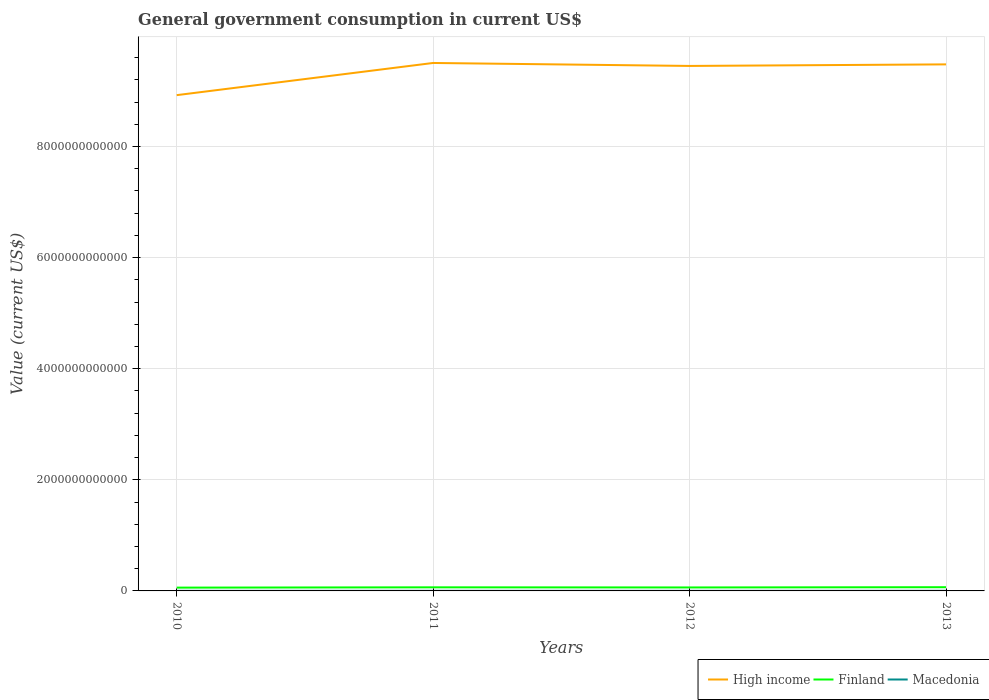How many different coloured lines are there?
Offer a very short reply. 3. Across all years, what is the maximum government conusmption in High income?
Give a very brief answer. 8.92e+12. In which year was the government conusmption in Macedonia maximum?
Keep it short and to the point. 2010. What is the total government conusmption in Macedonia in the graph?
Your answer should be very brief. -9.67e+07. What is the difference between the highest and the second highest government conusmption in High income?
Your answer should be very brief. 5.79e+11. Is the government conusmption in Finland strictly greater than the government conusmption in Macedonia over the years?
Your response must be concise. No. What is the difference between two consecutive major ticks on the Y-axis?
Provide a succinct answer. 2.00e+12. Does the graph contain any zero values?
Your answer should be compact. No. Where does the legend appear in the graph?
Provide a short and direct response. Bottom right. How many legend labels are there?
Your response must be concise. 3. How are the legend labels stacked?
Make the answer very short. Horizontal. What is the title of the graph?
Your answer should be compact. General government consumption in current US$. Does "Czech Republic" appear as one of the legend labels in the graph?
Your answer should be very brief. No. What is the label or title of the Y-axis?
Offer a very short reply. Value (current US$). What is the Value (current US$) of High income in 2010?
Your answer should be compact. 8.92e+12. What is the Value (current US$) in Finland in 2010?
Your answer should be compact. 5.92e+1. What is the Value (current US$) in Macedonia in 2010?
Ensure brevity in your answer.  1.72e+09. What is the Value (current US$) in High income in 2011?
Ensure brevity in your answer.  9.50e+12. What is the Value (current US$) of Finland in 2011?
Your answer should be very brief. 6.46e+1. What is the Value (current US$) in Macedonia in 2011?
Give a very brief answer. 1.90e+09. What is the Value (current US$) in High income in 2012?
Make the answer very short. 9.45e+12. What is the Value (current US$) in Finland in 2012?
Your answer should be very brief. 6.25e+1. What is the Value (current US$) in Macedonia in 2012?
Offer a very short reply. 1.82e+09. What is the Value (current US$) in High income in 2013?
Provide a succinct answer. 9.48e+12. What is the Value (current US$) of Finland in 2013?
Give a very brief answer. 6.68e+1. What is the Value (current US$) of Macedonia in 2013?
Ensure brevity in your answer.  1.91e+09. Across all years, what is the maximum Value (current US$) in High income?
Give a very brief answer. 9.50e+12. Across all years, what is the maximum Value (current US$) of Finland?
Ensure brevity in your answer.  6.68e+1. Across all years, what is the maximum Value (current US$) of Macedonia?
Provide a succinct answer. 1.91e+09. Across all years, what is the minimum Value (current US$) in High income?
Ensure brevity in your answer.  8.92e+12. Across all years, what is the minimum Value (current US$) of Finland?
Keep it short and to the point. 5.92e+1. Across all years, what is the minimum Value (current US$) of Macedonia?
Provide a short and direct response. 1.72e+09. What is the total Value (current US$) of High income in the graph?
Provide a short and direct response. 3.74e+13. What is the total Value (current US$) of Finland in the graph?
Provide a succinct answer. 2.53e+11. What is the total Value (current US$) of Macedonia in the graph?
Provide a succinct answer. 7.35e+09. What is the difference between the Value (current US$) in High income in 2010 and that in 2011?
Offer a terse response. -5.79e+11. What is the difference between the Value (current US$) in Finland in 2010 and that in 2011?
Give a very brief answer. -5.42e+09. What is the difference between the Value (current US$) of Macedonia in 2010 and that in 2011?
Offer a terse response. -1.81e+08. What is the difference between the Value (current US$) in High income in 2010 and that in 2012?
Your answer should be compact. -5.26e+11. What is the difference between the Value (current US$) of Finland in 2010 and that in 2012?
Offer a very short reply. -3.34e+09. What is the difference between the Value (current US$) of Macedonia in 2010 and that in 2012?
Give a very brief answer. -9.67e+07. What is the difference between the Value (current US$) of High income in 2010 and that in 2013?
Make the answer very short. -5.54e+11. What is the difference between the Value (current US$) of Finland in 2010 and that in 2013?
Your answer should be compact. -7.59e+09. What is the difference between the Value (current US$) of Macedonia in 2010 and that in 2013?
Offer a terse response. -1.86e+08. What is the difference between the Value (current US$) in High income in 2011 and that in 2012?
Your response must be concise. 5.35e+1. What is the difference between the Value (current US$) in Finland in 2011 and that in 2012?
Your answer should be compact. 2.08e+09. What is the difference between the Value (current US$) in Macedonia in 2011 and that in 2012?
Ensure brevity in your answer.  8.44e+07. What is the difference between the Value (current US$) in High income in 2011 and that in 2013?
Ensure brevity in your answer.  2.52e+1. What is the difference between the Value (current US$) of Finland in 2011 and that in 2013?
Keep it short and to the point. -2.18e+09. What is the difference between the Value (current US$) in Macedonia in 2011 and that in 2013?
Your answer should be compact. -4.93e+06. What is the difference between the Value (current US$) in High income in 2012 and that in 2013?
Offer a very short reply. -2.83e+1. What is the difference between the Value (current US$) of Finland in 2012 and that in 2013?
Offer a terse response. -4.25e+09. What is the difference between the Value (current US$) in Macedonia in 2012 and that in 2013?
Offer a very short reply. -8.93e+07. What is the difference between the Value (current US$) in High income in 2010 and the Value (current US$) in Finland in 2011?
Offer a terse response. 8.86e+12. What is the difference between the Value (current US$) in High income in 2010 and the Value (current US$) in Macedonia in 2011?
Provide a short and direct response. 8.92e+12. What is the difference between the Value (current US$) in Finland in 2010 and the Value (current US$) in Macedonia in 2011?
Your response must be concise. 5.73e+1. What is the difference between the Value (current US$) in High income in 2010 and the Value (current US$) in Finland in 2012?
Your answer should be very brief. 8.86e+12. What is the difference between the Value (current US$) of High income in 2010 and the Value (current US$) of Macedonia in 2012?
Offer a very short reply. 8.92e+12. What is the difference between the Value (current US$) in Finland in 2010 and the Value (current US$) in Macedonia in 2012?
Give a very brief answer. 5.74e+1. What is the difference between the Value (current US$) of High income in 2010 and the Value (current US$) of Finland in 2013?
Provide a short and direct response. 8.86e+12. What is the difference between the Value (current US$) in High income in 2010 and the Value (current US$) in Macedonia in 2013?
Your answer should be compact. 8.92e+12. What is the difference between the Value (current US$) in Finland in 2010 and the Value (current US$) in Macedonia in 2013?
Ensure brevity in your answer.  5.73e+1. What is the difference between the Value (current US$) in High income in 2011 and the Value (current US$) in Finland in 2012?
Offer a very short reply. 9.44e+12. What is the difference between the Value (current US$) in High income in 2011 and the Value (current US$) in Macedonia in 2012?
Your response must be concise. 9.50e+12. What is the difference between the Value (current US$) in Finland in 2011 and the Value (current US$) in Macedonia in 2012?
Keep it short and to the point. 6.28e+1. What is the difference between the Value (current US$) in High income in 2011 and the Value (current US$) in Finland in 2013?
Give a very brief answer. 9.44e+12. What is the difference between the Value (current US$) in High income in 2011 and the Value (current US$) in Macedonia in 2013?
Give a very brief answer. 9.50e+12. What is the difference between the Value (current US$) in Finland in 2011 and the Value (current US$) in Macedonia in 2013?
Offer a very short reply. 6.27e+1. What is the difference between the Value (current US$) of High income in 2012 and the Value (current US$) of Finland in 2013?
Your response must be concise. 9.38e+12. What is the difference between the Value (current US$) in High income in 2012 and the Value (current US$) in Macedonia in 2013?
Ensure brevity in your answer.  9.45e+12. What is the difference between the Value (current US$) of Finland in 2012 and the Value (current US$) of Macedonia in 2013?
Provide a short and direct response. 6.06e+1. What is the average Value (current US$) of High income per year?
Keep it short and to the point. 9.34e+12. What is the average Value (current US$) of Finland per year?
Keep it short and to the point. 6.33e+1. What is the average Value (current US$) of Macedonia per year?
Offer a very short reply. 1.84e+09. In the year 2010, what is the difference between the Value (current US$) in High income and Value (current US$) in Finland?
Offer a very short reply. 8.86e+12. In the year 2010, what is the difference between the Value (current US$) of High income and Value (current US$) of Macedonia?
Offer a very short reply. 8.92e+12. In the year 2010, what is the difference between the Value (current US$) of Finland and Value (current US$) of Macedonia?
Give a very brief answer. 5.75e+1. In the year 2011, what is the difference between the Value (current US$) in High income and Value (current US$) in Finland?
Offer a terse response. 9.44e+12. In the year 2011, what is the difference between the Value (current US$) of High income and Value (current US$) of Macedonia?
Ensure brevity in your answer.  9.50e+12. In the year 2011, what is the difference between the Value (current US$) in Finland and Value (current US$) in Macedonia?
Provide a succinct answer. 6.27e+1. In the year 2012, what is the difference between the Value (current US$) of High income and Value (current US$) of Finland?
Your response must be concise. 9.39e+12. In the year 2012, what is the difference between the Value (current US$) of High income and Value (current US$) of Macedonia?
Provide a short and direct response. 9.45e+12. In the year 2012, what is the difference between the Value (current US$) of Finland and Value (current US$) of Macedonia?
Offer a very short reply. 6.07e+1. In the year 2013, what is the difference between the Value (current US$) of High income and Value (current US$) of Finland?
Offer a very short reply. 9.41e+12. In the year 2013, what is the difference between the Value (current US$) in High income and Value (current US$) in Macedonia?
Give a very brief answer. 9.48e+12. In the year 2013, what is the difference between the Value (current US$) in Finland and Value (current US$) in Macedonia?
Offer a terse response. 6.49e+1. What is the ratio of the Value (current US$) of High income in 2010 to that in 2011?
Keep it short and to the point. 0.94. What is the ratio of the Value (current US$) in Finland in 2010 to that in 2011?
Keep it short and to the point. 0.92. What is the ratio of the Value (current US$) in Macedonia in 2010 to that in 2011?
Your answer should be compact. 0.9. What is the ratio of the Value (current US$) of High income in 2010 to that in 2012?
Ensure brevity in your answer.  0.94. What is the ratio of the Value (current US$) of Finland in 2010 to that in 2012?
Your answer should be very brief. 0.95. What is the ratio of the Value (current US$) of Macedonia in 2010 to that in 2012?
Provide a succinct answer. 0.95. What is the ratio of the Value (current US$) in High income in 2010 to that in 2013?
Offer a terse response. 0.94. What is the ratio of the Value (current US$) of Finland in 2010 to that in 2013?
Provide a succinct answer. 0.89. What is the ratio of the Value (current US$) in Macedonia in 2010 to that in 2013?
Provide a short and direct response. 0.9. What is the ratio of the Value (current US$) in High income in 2011 to that in 2012?
Offer a terse response. 1.01. What is the ratio of the Value (current US$) in Finland in 2011 to that in 2012?
Offer a very short reply. 1.03. What is the ratio of the Value (current US$) in Macedonia in 2011 to that in 2012?
Provide a short and direct response. 1.05. What is the ratio of the Value (current US$) in High income in 2011 to that in 2013?
Give a very brief answer. 1. What is the ratio of the Value (current US$) in Finland in 2011 to that in 2013?
Your answer should be compact. 0.97. What is the ratio of the Value (current US$) in Macedonia in 2011 to that in 2013?
Make the answer very short. 1. What is the ratio of the Value (current US$) in High income in 2012 to that in 2013?
Provide a succinct answer. 1. What is the ratio of the Value (current US$) in Finland in 2012 to that in 2013?
Give a very brief answer. 0.94. What is the ratio of the Value (current US$) in Macedonia in 2012 to that in 2013?
Give a very brief answer. 0.95. What is the difference between the highest and the second highest Value (current US$) of High income?
Keep it short and to the point. 2.52e+1. What is the difference between the highest and the second highest Value (current US$) in Finland?
Your answer should be very brief. 2.18e+09. What is the difference between the highest and the second highest Value (current US$) in Macedonia?
Your answer should be very brief. 4.93e+06. What is the difference between the highest and the lowest Value (current US$) of High income?
Give a very brief answer. 5.79e+11. What is the difference between the highest and the lowest Value (current US$) of Finland?
Provide a short and direct response. 7.59e+09. What is the difference between the highest and the lowest Value (current US$) in Macedonia?
Your response must be concise. 1.86e+08. 